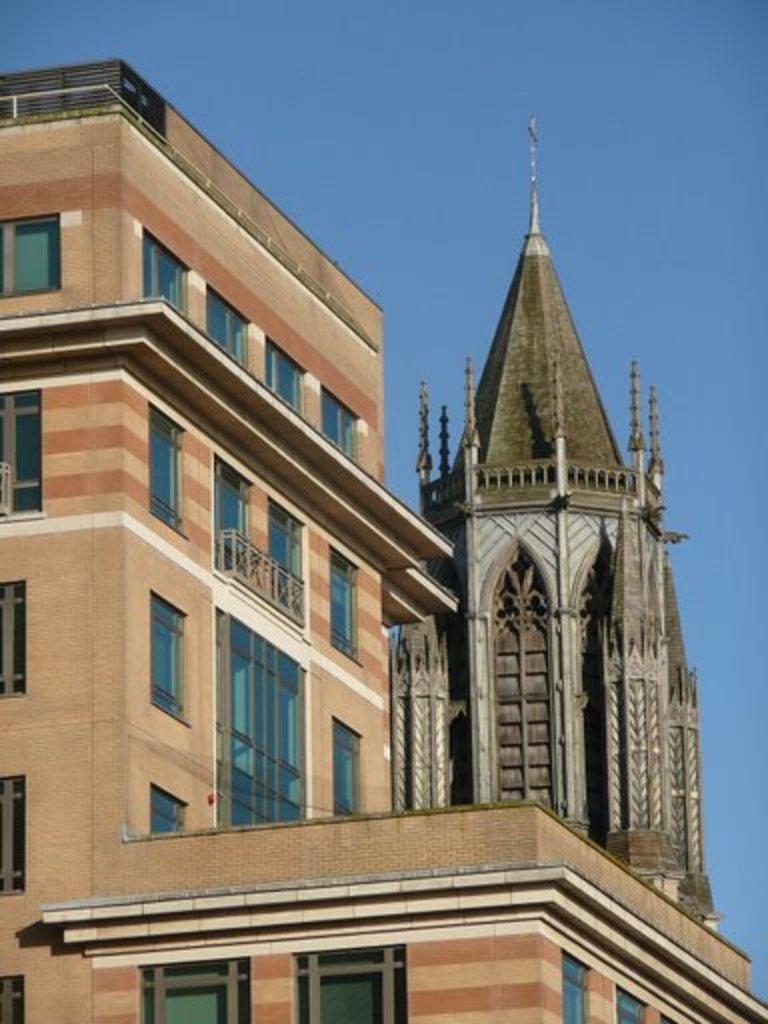Please provide a concise description of this image. In this image we can see a building and also the tower. Sky is also visible. 